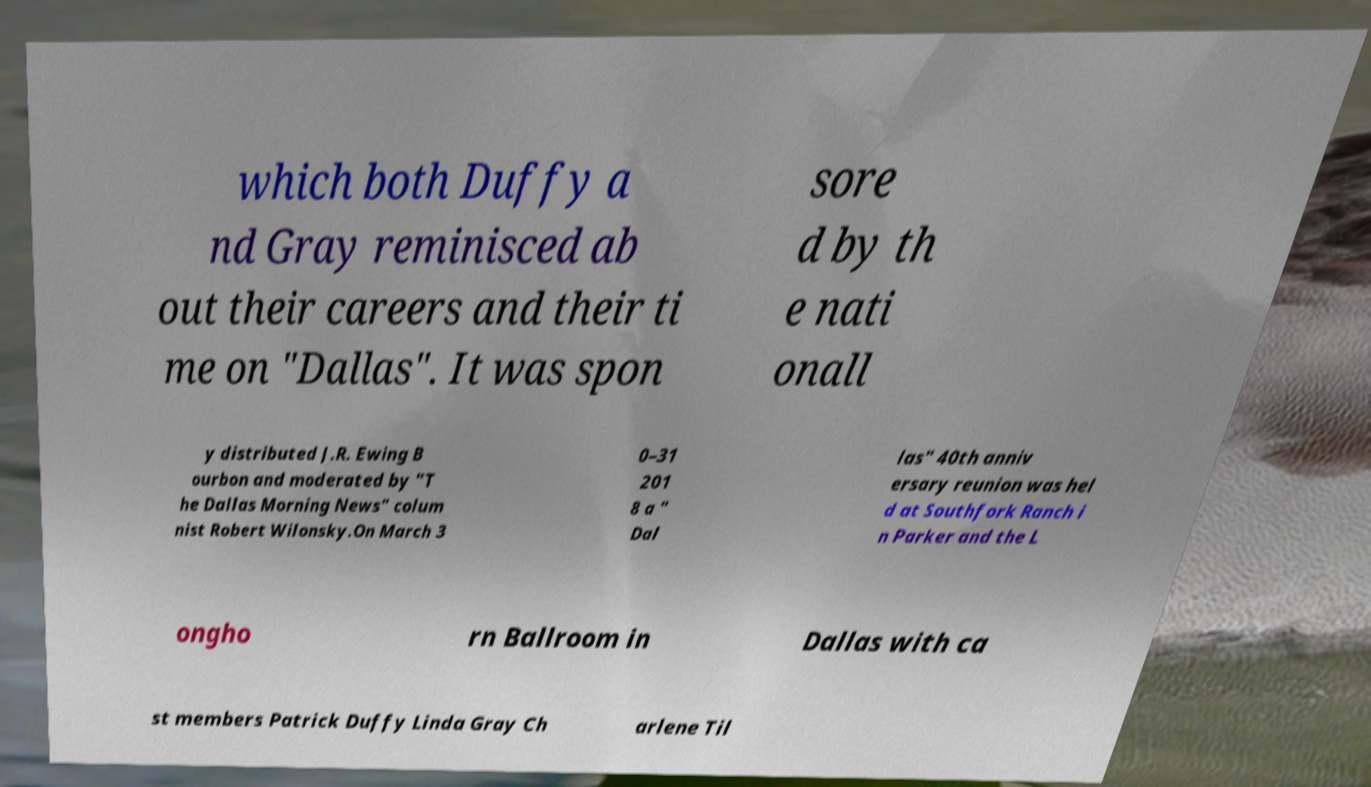Could you assist in decoding the text presented in this image and type it out clearly? which both Duffy a nd Gray reminisced ab out their careers and their ti me on "Dallas". It was spon sore d by th e nati onall y distributed J.R. Ewing B ourbon and moderated by "T he Dallas Morning News" colum nist Robert Wilonsky.On March 3 0–31 201 8 a " Dal las" 40th anniv ersary reunion was hel d at Southfork Ranch i n Parker and the L ongho rn Ballroom in Dallas with ca st members Patrick Duffy Linda Gray Ch arlene Til 